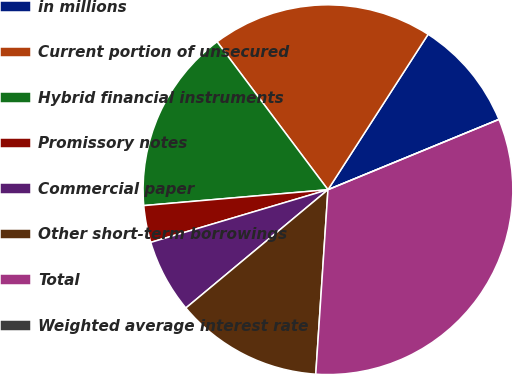<chart> <loc_0><loc_0><loc_500><loc_500><pie_chart><fcel>in millions<fcel>Current portion of unsecured<fcel>Hybrid financial instruments<fcel>Promissory notes<fcel>Commercial paper<fcel>Other short-term borrowings<fcel>Total<fcel>Weighted average interest rate<nl><fcel>9.68%<fcel>19.35%<fcel>16.13%<fcel>3.23%<fcel>6.45%<fcel>12.9%<fcel>32.26%<fcel>0.0%<nl></chart> 